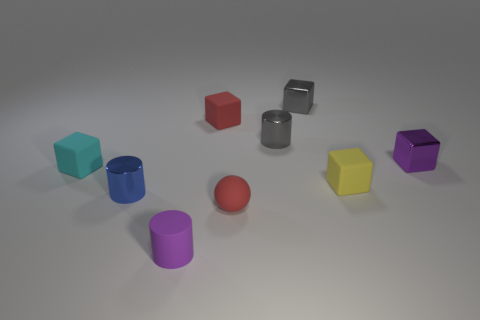Subtract all purple blocks. How many blocks are left? 4 Add 1 tiny purple cylinders. How many objects exist? 10 Subtract all blue cylinders. How many cylinders are left? 2 Subtract 1 cylinders. How many cylinders are left? 2 Add 3 small blue cylinders. How many small blue cylinders are left? 4 Add 6 large green metal blocks. How many large green metal blocks exist? 6 Subtract 0 green blocks. How many objects are left? 9 Subtract all cylinders. How many objects are left? 6 Subtract all blue cylinders. Subtract all cyan blocks. How many cylinders are left? 2 Subtract all red objects. Subtract all small shiny cubes. How many objects are left? 5 